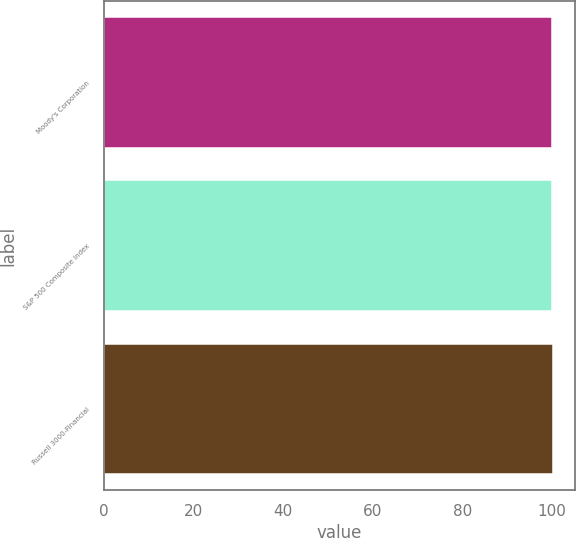<chart> <loc_0><loc_0><loc_500><loc_500><bar_chart><fcel>Moody's Corporation<fcel>S&P 500 Composite Index<fcel>Russell 3000-Financial<nl><fcel>100<fcel>100.1<fcel>100.2<nl></chart> 